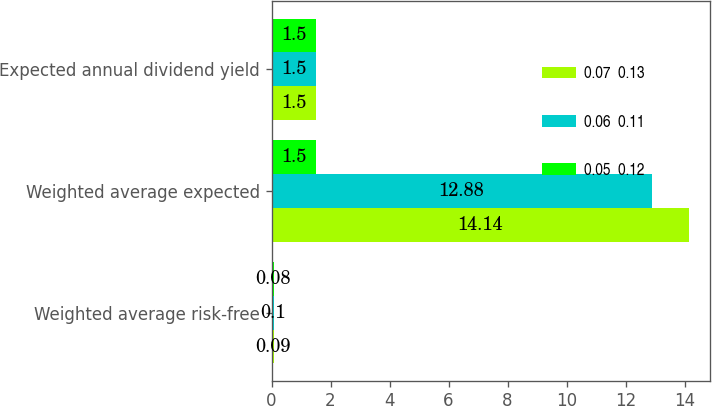Convert chart to OTSL. <chart><loc_0><loc_0><loc_500><loc_500><stacked_bar_chart><ecel><fcel>Weighted average risk-free<fcel>Weighted average expected<fcel>Expected annual dividend yield<nl><fcel>0.07  0.13<fcel>0.09<fcel>14.14<fcel>1.5<nl><fcel>0.06  0.11<fcel>0.1<fcel>12.88<fcel>1.5<nl><fcel>0.05  0.12<fcel>0.08<fcel>1.5<fcel>1.5<nl></chart> 